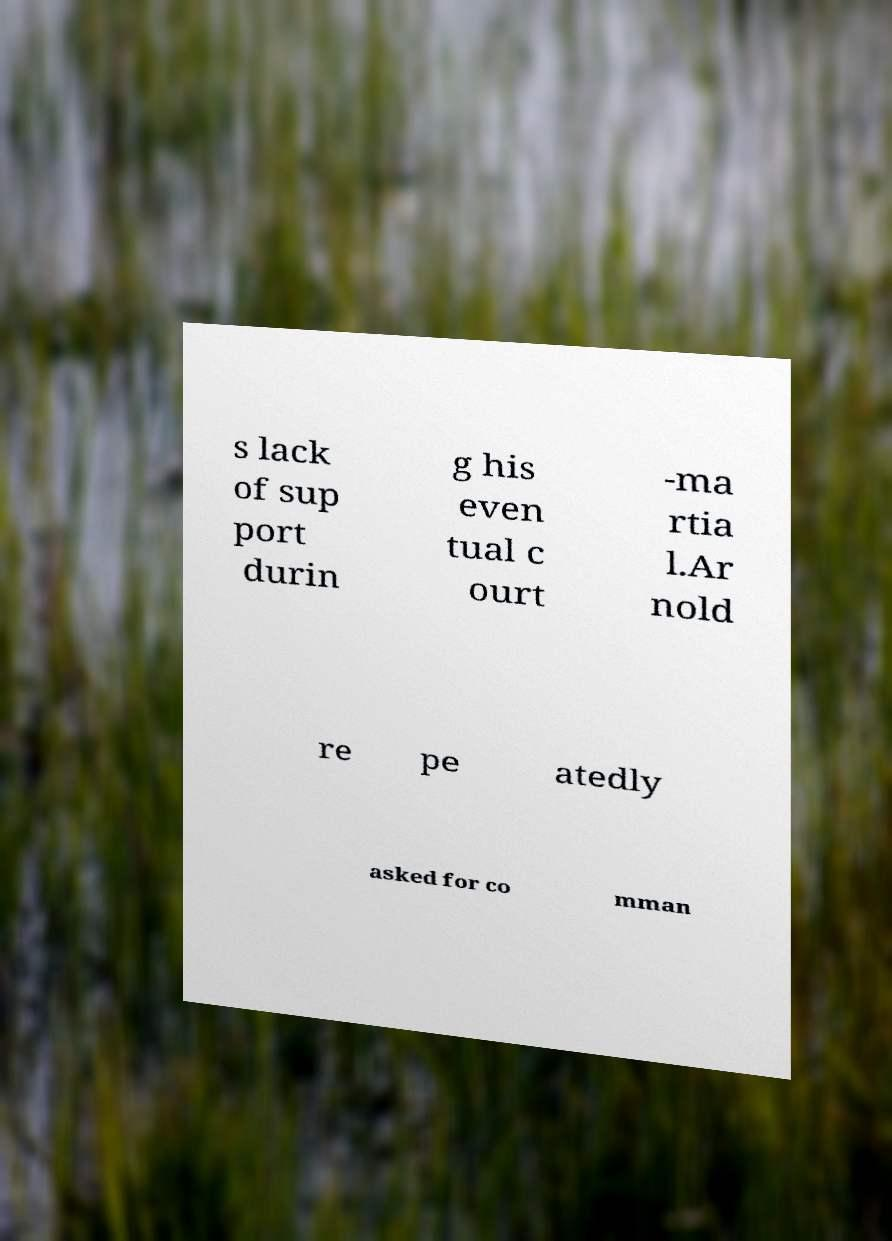Can you accurately transcribe the text from the provided image for me? s lack of sup port durin g his even tual c ourt -ma rtia l.Ar nold re pe atedly asked for co mman 